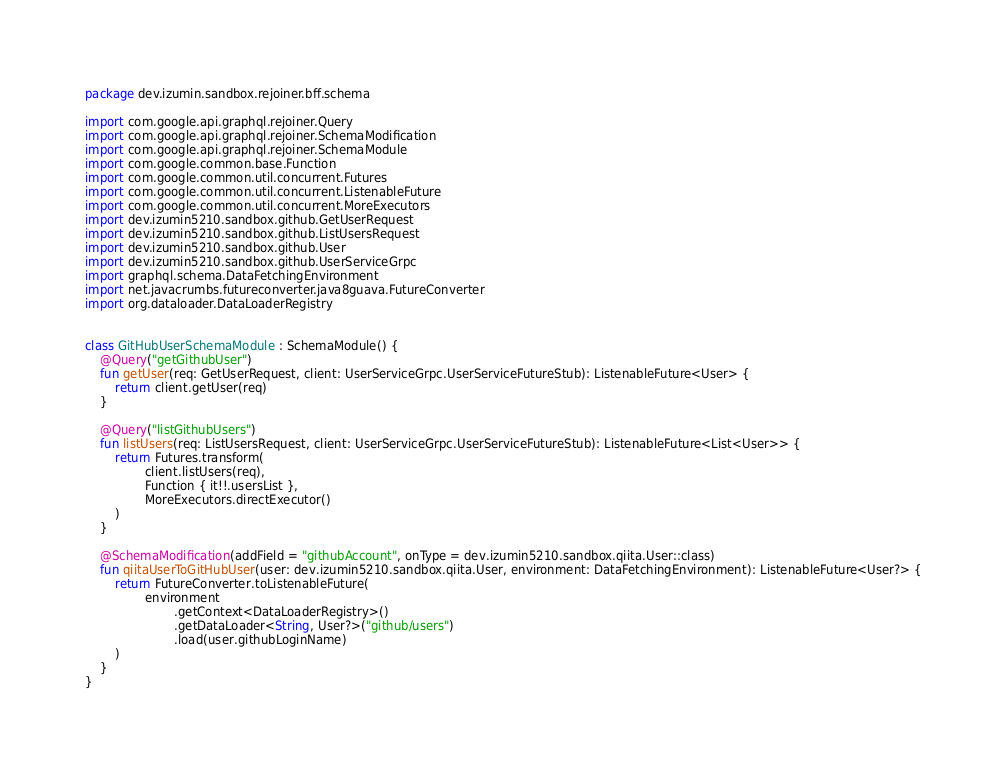<code> <loc_0><loc_0><loc_500><loc_500><_Kotlin_>package dev.izumin.sandbox.rejoiner.bff.schema

import com.google.api.graphql.rejoiner.Query
import com.google.api.graphql.rejoiner.SchemaModification
import com.google.api.graphql.rejoiner.SchemaModule
import com.google.common.base.Function
import com.google.common.util.concurrent.Futures
import com.google.common.util.concurrent.ListenableFuture
import com.google.common.util.concurrent.MoreExecutors
import dev.izumin5210.sandbox.github.GetUserRequest
import dev.izumin5210.sandbox.github.ListUsersRequest
import dev.izumin5210.sandbox.github.User
import dev.izumin5210.sandbox.github.UserServiceGrpc
import graphql.schema.DataFetchingEnvironment
import net.javacrumbs.futureconverter.java8guava.FutureConverter
import org.dataloader.DataLoaderRegistry


class GitHubUserSchemaModule : SchemaModule() {
    @Query("getGithubUser")
    fun getUser(req: GetUserRequest, client: UserServiceGrpc.UserServiceFutureStub): ListenableFuture<User> {
        return client.getUser(req)
    }

    @Query("listGithubUsers")
    fun listUsers(req: ListUsersRequest, client: UserServiceGrpc.UserServiceFutureStub): ListenableFuture<List<User>> {
        return Futures.transform(
                client.listUsers(req),
                Function { it!!.usersList },
                MoreExecutors.directExecutor()
        )
    }

    @SchemaModification(addField = "githubAccount", onType = dev.izumin5210.sandbox.qiita.User::class)
    fun qiitaUserToGitHubUser(user: dev.izumin5210.sandbox.qiita.User, environment: DataFetchingEnvironment): ListenableFuture<User?> {
        return FutureConverter.toListenableFuture(
                environment
                        .getContext<DataLoaderRegistry>()
                        .getDataLoader<String, User?>("github/users")
                        .load(user.githubLoginName)
        )
    }
}
</code> 